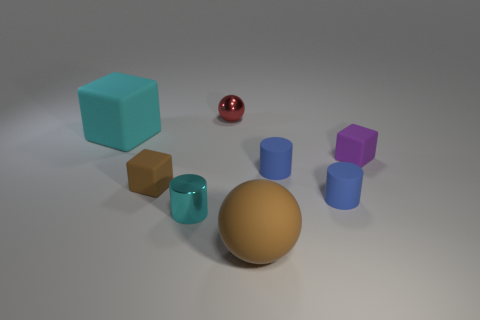Subtract all blue cubes. Subtract all gray cylinders. How many cubes are left? 3 Add 2 big brown things. How many objects exist? 10 Subtract all blocks. How many objects are left? 5 Add 5 tiny brown objects. How many tiny brown objects are left? 6 Add 4 small cylinders. How many small cylinders exist? 7 Subtract 0 purple balls. How many objects are left? 8 Subtract all tiny green rubber objects. Subtract all blue things. How many objects are left? 6 